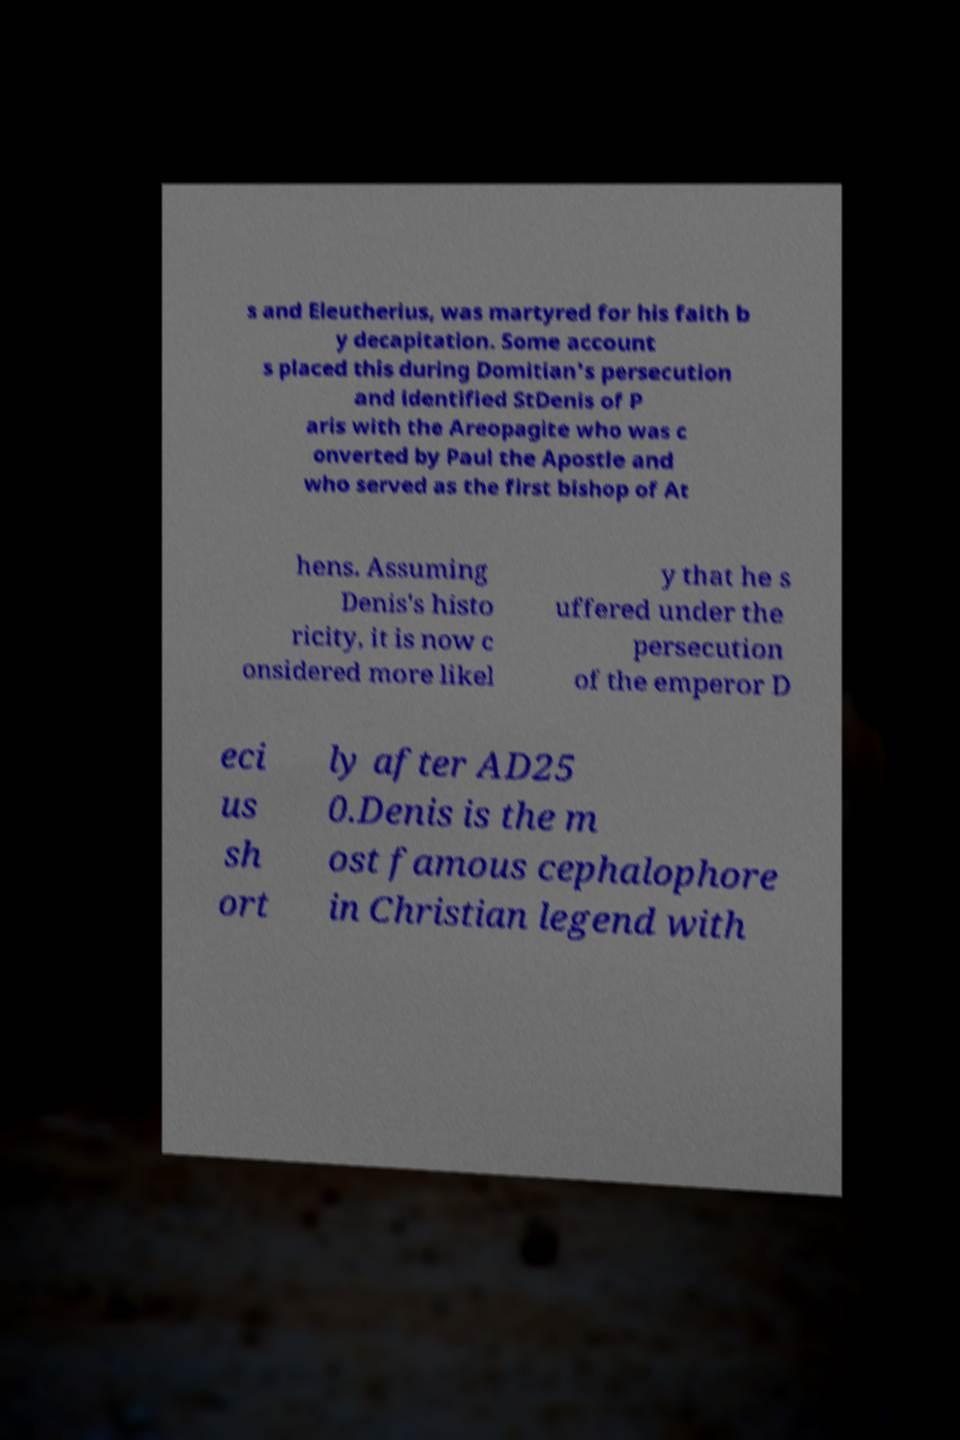Can you accurately transcribe the text from the provided image for me? s and Eleutherius, was martyred for his faith b y decapitation. Some account s placed this during Domitian's persecution and identified StDenis of P aris with the Areopagite who was c onverted by Paul the Apostle and who served as the first bishop of At hens. Assuming Denis's histo ricity, it is now c onsidered more likel y that he s uffered under the persecution of the emperor D eci us sh ort ly after AD25 0.Denis is the m ost famous cephalophore in Christian legend with 